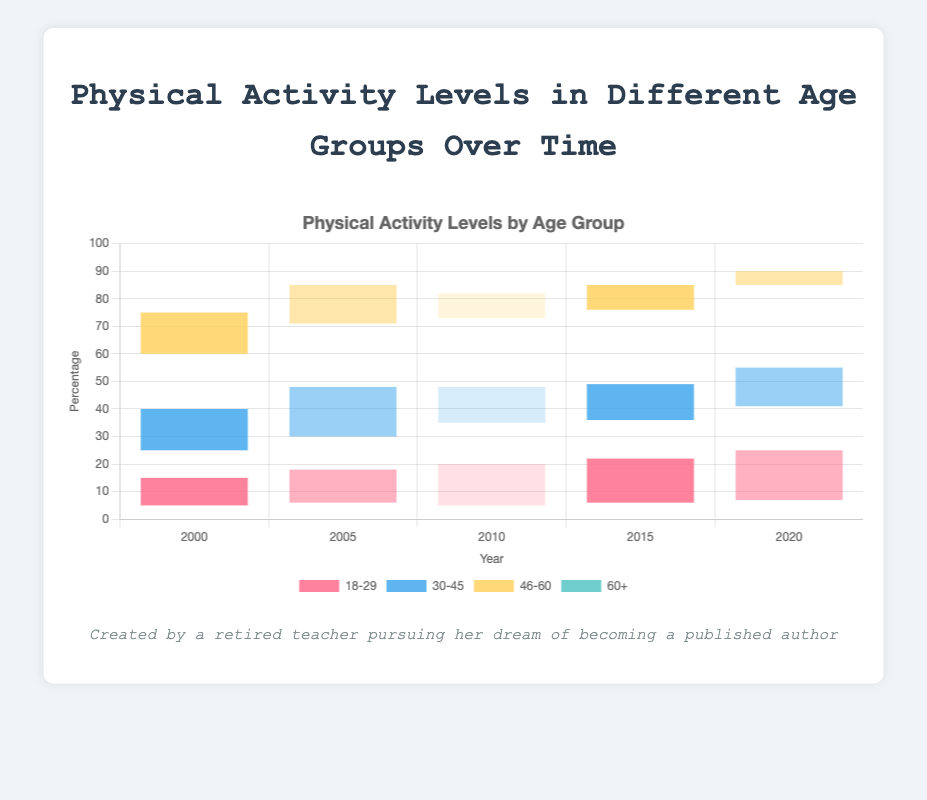What's the percentage of people in the 18-29 age group with high activity levels in the year 2000? In the figure, locate the bar for the year 2000 and the 18-29 age group, then observe the height corresponding to high activity levels - it is visually represented and labeled as 80%.
Answer: 80% In 2005, which age group had the highest percentage of low activity levels? To find the answer, identify and compare the height of the bars for low activity levels across all age groups for the year 2005. The 60+ group has the highest bar at 38%.
Answer: 60+ How did the percentage of moderate activity levels change for the 30-45 age group from 2000 to 2020? First, check the percentage values for moderate activity levels in the 30-45 age group in the years 2000 (25%) and 2020 (30%). Subtract the 2000 value from the 2020 value: 30% - 25% gives a 5% increase.
Answer: 5% increase Which age group saw the largest increase in low activity levels from 2000 to 2020? To determine this, track the percentages for low activity levels for each age group from 2000 to 2020. Calculate the difference for each group: 18-29 (7%-5%=2%), 30-45 (16%-10%=6%), 46-60 (30%-20%=10%), 60+ (45%-35%=10%). Both 46-60 and 60+ groups observed a 10% increase.
Answer: 46-60 and 60+ In 2010, how does the moderate activity level for the 46-60 age group compare to the 60+ age group for the same year? Locate the bars for these age groups in 2010 and compare the heights for moderate activity levels. For 46-60, it is 34%, and for 60+, it is 38%, indicating that the 60+ group has a marginally higher percentage.
Answer: 60+ group has higher moderate activity levels What can you say about the trend of high activity levels for the 18-29 age group over the years? Observe the heights of the bars representing high activity levels for the 18-29 age group from 2000 to 2020: 80% in 2000, 76% in 2005, 75% in 2010, 72% in 2015, and 68% in 2020. It shows a declining trend over the years.
Answer: Declining Calculate the average high activity level percentage of the 30-45 age group across all years. List the high activity level percentages for 30-45 across all years: 65%, 58%, 57%, 59%, 54%. Calculate the average: (65 + 58 + 57 + 59 + 54) / 5 = 58.6%.
Answer: 58.6% Compare the low activity levels in 2015 between the 46-60 and the 30-45 age groups. Find the heights of the bars representing low activity levels for the 46-60 (27%) and 30-45 (14%) age groups in 2015. The 46-60 group has a higher percentage than the 30-45 group.
Answer: 46-60 group has higher low activity levels Which age group showed the smallest change in high activity levels from 2000 to 2020? Calculate the change in high activity levels for each age group from 2000 to 2020: 18-29 (80%-68%=12%), 30-45 (65%-54%=11%), 46-60 (45%-35%=10%), 60+ (25%-20%=5%). The 60+ age group shows the smallest change.
Answer: 60+ 